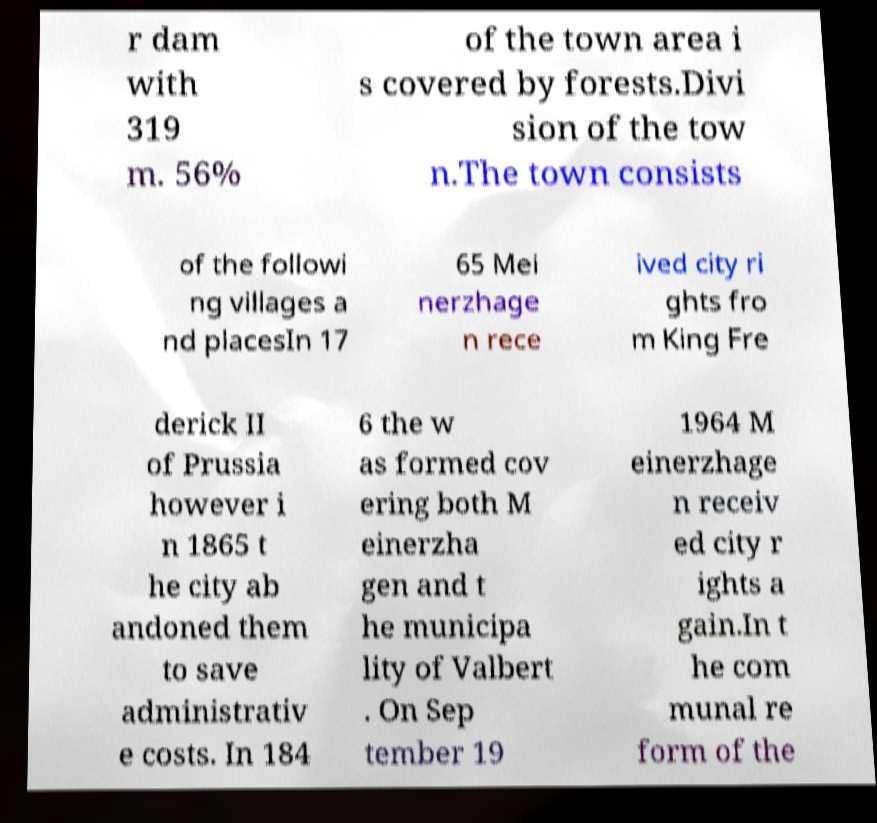Please identify and transcribe the text found in this image. r dam with 319 m. 56% of the town area i s covered by forests.Divi sion of the tow n.The town consists of the followi ng villages a nd placesIn 17 65 Mei nerzhage n rece ived city ri ghts fro m King Fre derick II of Prussia however i n 1865 t he city ab andoned them to save administrativ e costs. In 184 6 the w as formed cov ering both M einerzha gen and t he municipa lity of Valbert . On Sep tember 19 1964 M einerzhage n receiv ed city r ights a gain.In t he com munal re form of the 